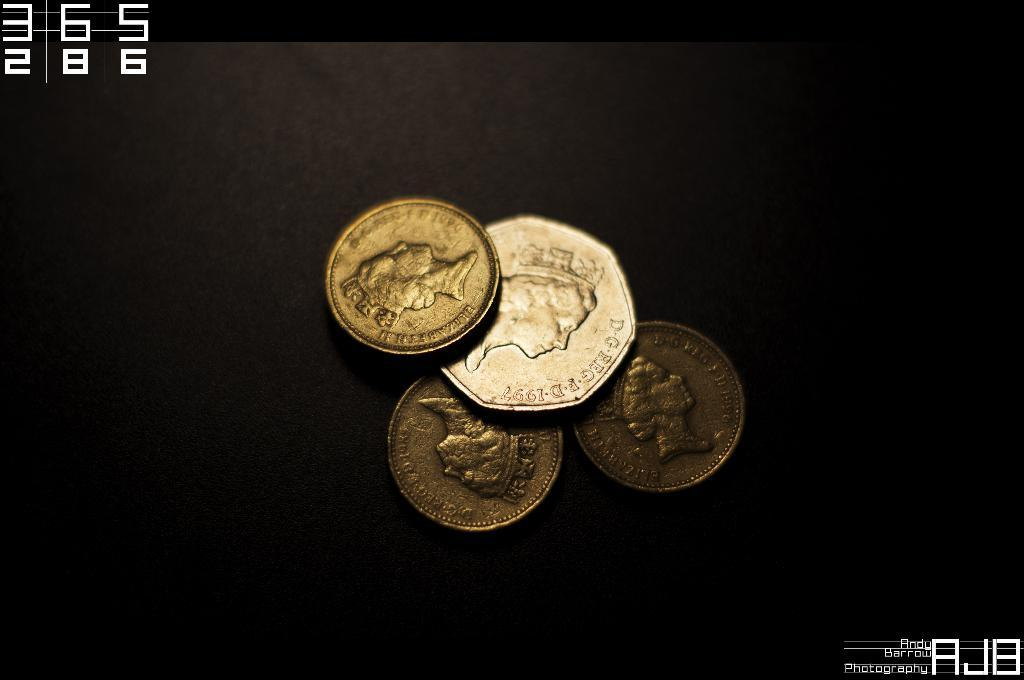Provide a one-sentence caption for the provided image. Some UK  coins with Elizabeth II written on the edge. 